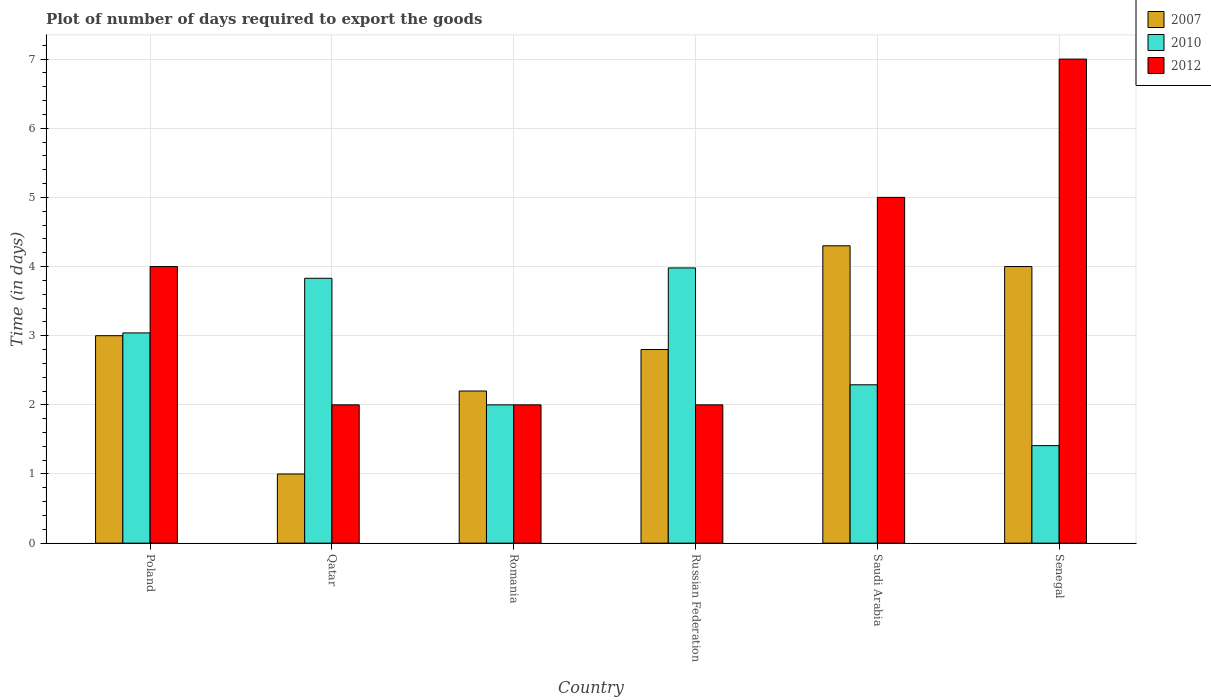How many groups of bars are there?
Provide a short and direct response. 6. How many bars are there on the 1st tick from the left?
Your answer should be very brief. 3. What is the label of the 3rd group of bars from the left?
Make the answer very short. Romania. In how many cases, is the number of bars for a given country not equal to the number of legend labels?
Offer a terse response. 0. What is the time required to export goods in 2012 in Senegal?
Your answer should be very brief. 7. Across all countries, what is the maximum time required to export goods in 2012?
Provide a succinct answer. 7. In which country was the time required to export goods in 2012 maximum?
Offer a very short reply. Senegal. In which country was the time required to export goods in 2007 minimum?
Make the answer very short. Qatar. What is the total time required to export goods in 2007 in the graph?
Offer a terse response. 17.3. What is the difference between the time required to export goods in 2007 in Romania and that in Russian Federation?
Give a very brief answer. -0.6. What is the difference between the time required to export goods in 2012 in Poland and the time required to export goods in 2010 in Senegal?
Provide a succinct answer. 2.59. What is the average time required to export goods in 2010 per country?
Keep it short and to the point. 2.76. In how many countries, is the time required to export goods in 2012 greater than 3.6 days?
Keep it short and to the point. 3. What is the ratio of the time required to export goods in 2007 in Saudi Arabia to that in Senegal?
Make the answer very short. 1.07. Is the time required to export goods in 2012 in Qatar less than that in Saudi Arabia?
Offer a very short reply. Yes. What is the difference between the highest and the second highest time required to export goods in 2007?
Provide a short and direct response. -1.3. What does the 1st bar from the left in Saudi Arabia represents?
Provide a succinct answer. 2007. What does the 2nd bar from the right in Qatar represents?
Provide a succinct answer. 2010. Is it the case that in every country, the sum of the time required to export goods in 2012 and time required to export goods in 2010 is greater than the time required to export goods in 2007?
Offer a terse response. Yes. Are all the bars in the graph horizontal?
Provide a succinct answer. No. How many countries are there in the graph?
Your answer should be compact. 6. What is the difference between two consecutive major ticks on the Y-axis?
Provide a succinct answer. 1. Are the values on the major ticks of Y-axis written in scientific E-notation?
Make the answer very short. No. How are the legend labels stacked?
Your response must be concise. Vertical. What is the title of the graph?
Ensure brevity in your answer.  Plot of number of days required to export the goods. What is the label or title of the Y-axis?
Offer a very short reply. Time (in days). What is the Time (in days) of 2007 in Poland?
Your answer should be very brief. 3. What is the Time (in days) in 2010 in Poland?
Your response must be concise. 3.04. What is the Time (in days) in 2012 in Poland?
Keep it short and to the point. 4. What is the Time (in days) of 2007 in Qatar?
Your answer should be very brief. 1. What is the Time (in days) in 2010 in Qatar?
Provide a succinct answer. 3.83. What is the Time (in days) in 2007 in Romania?
Make the answer very short. 2.2. What is the Time (in days) in 2007 in Russian Federation?
Your answer should be very brief. 2.8. What is the Time (in days) in 2010 in Russian Federation?
Offer a terse response. 3.98. What is the Time (in days) of 2012 in Russian Federation?
Give a very brief answer. 2. What is the Time (in days) in 2010 in Saudi Arabia?
Offer a terse response. 2.29. What is the Time (in days) in 2012 in Saudi Arabia?
Offer a terse response. 5. What is the Time (in days) in 2010 in Senegal?
Your response must be concise. 1.41. What is the Time (in days) in 2012 in Senegal?
Provide a succinct answer. 7. Across all countries, what is the maximum Time (in days) of 2010?
Make the answer very short. 3.98. Across all countries, what is the minimum Time (in days) of 2010?
Your answer should be very brief. 1.41. What is the total Time (in days) of 2007 in the graph?
Your response must be concise. 17.3. What is the total Time (in days) of 2010 in the graph?
Offer a terse response. 16.55. What is the difference between the Time (in days) of 2007 in Poland and that in Qatar?
Provide a succinct answer. 2. What is the difference between the Time (in days) in 2010 in Poland and that in Qatar?
Give a very brief answer. -0.79. What is the difference between the Time (in days) in 2007 in Poland and that in Romania?
Your answer should be compact. 0.8. What is the difference between the Time (in days) in 2010 in Poland and that in Romania?
Your response must be concise. 1.04. What is the difference between the Time (in days) of 2012 in Poland and that in Romania?
Offer a terse response. 2. What is the difference between the Time (in days) of 2010 in Poland and that in Russian Federation?
Ensure brevity in your answer.  -0.94. What is the difference between the Time (in days) of 2007 in Poland and that in Saudi Arabia?
Your answer should be compact. -1.3. What is the difference between the Time (in days) of 2010 in Poland and that in Saudi Arabia?
Give a very brief answer. 0.75. What is the difference between the Time (in days) of 2012 in Poland and that in Saudi Arabia?
Give a very brief answer. -1. What is the difference between the Time (in days) of 2007 in Poland and that in Senegal?
Give a very brief answer. -1. What is the difference between the Time (in days) in 2010 in Poland and that in Senegal?
Keep it short and to the point. 1.63. What is the difference between the Time (in days) in 2010 in Qatar and that in Romania?
Provide a short and direct response. 1.83. What is the difference between the Time (in days) in 2010 in Qatar and that in Saudi Arabia?
Keep it short and to the point. 1.54. What is the difference between the Time (in days) in 2007 in Qatar and that in Senegal?
Keep it short and to the point. -3. What is the difference between the Time (in days) of 2010 in Qatar and that in Senegal?
Offer a terse response. 2.42. What is the difference between the Time (in days) of 2007 in Romania and that in Russian Federation?
Your response must be concise. -0.6. What is the difference between the Time (in days) in 2010 in Romania and that in Russian Federation?
Your answer should be very brief. -1.98. What is the difference between the Time (in days) in 2010 in Romania and that in Saudi Arabia?
Your answer should be very brief. -0.29. What is the difference between the Time (in days) in 2012 in Romania and that in Saudi Arabia?
Keep it short and to the point. -3. What is the difference between the Time (in days) in 2007 in Romania and that in Senegal?
Your answer should be very brief. -1.8. What is the difference between the Time (in days) in 2010 in Romania and that in Senegal?
Ensure brevity in your answer.  0.59. What is the difference between the Time (in days) of 2012 in Romania and that in Senegal?
Your answer should be compact. -5. What is the difference between the Time (in days) in 2007 in Russian Federation and that in Saudi Arabia?
Ensure brevity in your answer.  -1.5. What is the difference between the Time (in days) of 2010 in Russian Federation and that in Saudi Arabia?
Offer a very short reply. 1.69. What is the difference between the Time (in days) of 2007 in Russian Federation and that in Senegal?
Keep it short and to the point. -1.2. What is the difference between the Time (in days) in 2010 in Russian Federation and that in Senegal?
Keep it short and to the point. 2.57. What is the difference between the Time (in days) in 2012 in Russian Federation and that in Senegal?
Your answer should be compact. -5. What is the difference between the Time (in days) in 2007 in Saudi Arabia and that in Senegal?
Give a very brief answer. 0.3. What is the difference between the Time (in days) of 2012 in Saudi Arabia and that in Senegal?
Give a very brief answer. -2. What is the difference between the Time (in days) in 2007 in Poland and the Time (in days) in 2010 in Qatar?
Keep it short and to the point. -0.83. What is the difference between the Time (in days) of 2007 in Poland and the Time (in days) of 2012 in Romania?
Provide a short and direct response. 1. What is the difference between the Time (in days) of 2007 in Poland and the Time (in days) of 2010 in Russian Federation?
Your answer should be compact. -0.98. What is the difference between the Time (in days) in 2007 in Poland and the Time (in days) in 2012 in Russian Federation?
Keep it short and to the point. 1. What is the difference between the Time (in days) of 2007 in Poland and the Time (in days) of 2010 in Saudi Arabia?
Ensure brevity in your answer.  0.71. What is the difference between the Time (in days) of 2007 in Poland and the Time (in days) of 2012 in Saudi Arabia?
Offer a terse response. -2. What is the difference between the Time (in days) in 2010 in Poland and the Time (in days) in 2012 in Saudi Arabia?
Your response must be concise. -1.96. What is the difference between the Time (in days) in 2007 in Poland and the Time (in days) in 2010 in Senegal?
Give a very brief answer. 1.59. What is the difference between the Time (in days) of 2007 in Poland and the Time (in days) of 2012 in Senegal?
Provide a short and direct response. -4. What is the difference between the Time (in days) of 2010 in Poland and the Time (in days) of 2012 in Senegal?
Keep it short and to the point. -3.96. What is the difference between the Time (in days) of 2007 in Qatar and the Time (in days) of 2010 in Romania?
Offer a very short reply. -1. What is the difference between the Time (in days) in 2010 in Qatar and the Time (in days) in 2012 in Romania?
Offer a terse response. 1.83. What is the difference between the Time (in days) of 2007 in Qatar and the Time (in days) of 2010 in Russian Federation?
Your answer should be very brief. -2.98. What is the difference between the Time (in days) of 2007 in Qatar and the Time (in days) of 2012 in Russian Federation?
Offer a very short reply. -1. What is the difference between the Time (in days) of 2010 in Qatar and the Time (in days) of 2012 in Russian Federation?
Give a very brief answer. 1.83. What is the difference between the Time (in days) of 2007 in Qatar and the Time (in days) of 2010 in Saudi Arabia?
Your answer should be compact. -1.29. What is the difference between the Time (in days) of 2007 in Qatar and the Time (in days) of 2012 in Saudi Arabia?
Provide a succinct answer. -4. What is the difference between the Time (in days) of 2010 in Qatar and the Time (in days) of 2012 in Saudi Arabia?
Your answer should be very brief. -1.17. What is the difference between the Time (in days) of 2007 in Qatar and the Time (in days) of 2010 in Senegal?
Provide a short and direct response. -0.41. What is the difference between the Time (in days) of 2010 in Qatar and the Time (in days) of 2012 in Senegal?
Offer a very short reply. -3.17. What is the difference between the Time (in days) in 2007 in Romania and the Time (in days) in 2010 in Russian Federation?
Your answer should be very brief. -1.78. What is the difference between the Time (in days) of 2010 in Romania and the Time (in days) of 2012 in Russian Federation?
Your answer should be compact. 0. What is the difference between the Time (in days) in 2007 in Romania and the Time (in days) in 2010 in Saudi Arabia?
Ensure brevity in your answer.  -0.09. What is the difference between the Time (in days) of 2007 in Romania and the Time (in days) of 2012 in Saudi Arabia?
Provide a short and direct response. -2.8. What is the difference between the Time (in days) in 2010 in Romania and the Time (in days) in 2012 in Saudi Arabia?
Provide a succinct answer. -3. What is the difference between the Time (in days) in 2007 in Romania and the Time (in days) in 2010 in Senegal?
Provide a succinct answer. 0.79. What is the difference between the Time (in days) of 2007 in Romania and the Time (in days) of 2012 in Senegal?
Provide a short and direct response. -4.8. What is the difference between the Time (in days) in 2010 in Romania and the Time (in days) in 2012 in Senegal?
Provide a short and direct response. -5. What is the difference between the Time (in days) in 2007 in Russian Federation and the Time (in days) in 2010 in Saudi Arabia?
Offer a terse response. 0.51. What is the difference between the Time (in days) in 2010 in Russian Federation and the Time (in days) in 2012 in Saudi Arabia?
Give a very brief answer. -1.02. What is the difference between the Time (in days) in 2007 in Russian Federation and the Time (in days) in 2010 in Senegal?
Give a very brief answer. 1.39. What is the difference between the Time (in days) in 2007 in Russian Federation and the Time (in days) in 2012 in Senegal?
Make the answer very short. -4.2. What is the difference between the Time (in days) in 2010 in Russian Federation and the Time (in days) in 2012 in Senegal?
Ensure brevity in your answer.  -3.02. What is the difference between the Time (in days) of 2007 in Saudi Arabia and the Time (in days) of 2010 in Senegal?
Your answer should be compact. 2.89. What is the difference between the Time (in days) of 2010 in Saudi Arabia and the Time (in days) of 2012 in Senegal?
Offer a very short reply. -4.71. What is the average Time (in days) of 2007 per country?
Make the answer very short. 2.88. What is the average Time (in days) in 2010 per country?
Keep it short and to the point. 2.76. What is the average Time (in days) of 2012 per country?
Your answer should be compact. 3.67. What is the difference between the Time (in days) of 2007 and Time (in days) of 2010 in Poland?
Give a very brief answer. -0.04. What is the difference between the Time (in days) of 2007 and Time (in days) of 2012 in Poland?
Offer a very short reply. -1. What is the difference between the Time (in days) of 2010 and Time (in days) of 2012 in Poland?
Your answer should be compact. -0.96. What is the difference between the Time (in days) of 2007 and Time (in days) of 2010 in Qatar?
Ensure brevity in your answer.  -2.83. What is the difference between the Time (in days) in 2007 and Time (in days) in 2012 in Qatar?
Make the answer very short. -1. What is the difference between the Time (in days) of 2010 and Time (in days) of 2012 in Qatar?
Ensure brevity in your answer.  1.83. What is the difference between the Time (in days) in 2007 and Time (in days) in 2012 in Romania?
Your response must be concise. 0.2. What is the difference between the Time (in days) in 2010 and Time (in days) in 2012 in Romania?
Ensure brevity in your answer.  0. What is the difference between the Time (in days) in 2007 and Time (in days) in 2010 in Russian Federation?
Provide a succinct answer. -1.18. What is the difference between the Time (in days) in 2007 and Time (in days) in 2012 in Russian Federation?
Your response must be concise. 0.8. What is the difference between the Time (in days) in 2010 and Time (in days) in 2012 in Russian Federation?
Offer a very short reply. 1.98. What is the difference between the Time (in days) in 2007 and Time (in days) in 2010 in Saudi Arabia?
Keep it short and to the point. 2.01. What is the difference between the Time (in days) in 2007 and Time (in days) in 2012 in Saudi Arabia?
Ensure brevity in your answer.  -0.7. What is the difference between the Time (in days) of 2010 and Time (in days) of 2012 in Saudi Arabia?
Offer a terse response. -2.71. What is the difference between the Time (in days) in 2007 and Time (in days) in 2010 in Senegal?
Offer a terse response. 2.59. What is the difference between the Time (in days) in 2010 and Time (in days) in 2012 in Senegal?
Provide a short and direct response. -5.59. What is the ratio of the Time (in days) of 2010 in Poland to that in Qatar?
Offer a very short reply. 0.79. What is the ratio of the Time (in days) in 2012 in Poland to that in Qatar?
Your response must be concise. 2. What is the ratio of the Time (in days) in 2007 in Poland to that in Romania?
Your answer should be very brief. 1.36. What is the ratio of the Time (in days) of 2010 in Poland to that in Romania?
Your answer should be compact. 1.52. What is the ratio of the Time (in days) of 2007 in Poland to that in Russian Federation?
Keep it short and to the point. 1.07. What is the ratio of the Time (in days) in 2010 in Poland to that in Russian Federation?
Keep it short and to the point. 0.76. What is the ratio of the Time (in days) of 2007 in Poland to that in Saudi Arabia?
Provide a short and direct response. 0.7. What is the ratio of the Time (in days) of 2010 in Poland to that in Saudi Arabia?
Ensure brevity in your answer.  1.33. What is the ratio of the Time (in days) of 2010 in Poland to that in Senegal?
Make the answer very short. 2.16. What is the ratio of the Time (in days) in 2012 in Poland to that in Senegal?
Your answer should be very brief. 0.57. What is the ratio of the Time (in days) in 2007 in Qatar to that in Romania?
Your response must be concise. 0.45. What is the ratio of the Time (in days) in 2010 in Qatar to that in Romania?
Provide a short and direct response. 1.92. What is the ratio of the Time (in days) of 2012 in Qatar to that in Romania?
Your response must be concise. 1. What is the ratio of the Time (in days) in 2007 in Qatar to that in Russian Federation?
Ensure brevity in your answer.  0.36. What is the ratio of the Time (in days) in 2010 in Qatar to that in Russian Federation?
Ensure brevity in your answer.  0.96. What is the ratio of the Time (in days) in 2007 in Qatar to that in Saudi Arabia?
Provide a short and direct response. 0.23. What is the ratio of the Time (in days) in 2010 in Qatar to that in Saudi Arabia?
Keep it short and to the point. 1.67. What is the ratio of the Time (in days) of 2010 in Qatar to that in Senegal?
Your response must be concise. 2.72. What is the ratio of the Time (in days) of 2012 in Qatar to that in Senegal?
Give a very brief answer. 0.29. What is the ratio of the Time (in days) of 2007 in Romania to that in Russian Federation?
Your answer should be compact. 0.79. What is the ratio of the Time (in days) of 2010 in Romania to that in Russian Federation?
Offer a terse response. 0.5. What is the ratio of the Time (in days) in 2012 in Romania to that in Russian Federation?
Give a very brief answer. 1. What is the ratio of the Time (in days) of 2007 in Romania to that in Saudi Arabia?
Keep it short and to the point. 0.51. What is the ratio of the Time (in days) in 2010 in Romania to that in Saudi Arabia?
Provide a succinct answer. 0.87. What is the ratio of the Time (in days) in 2007 in Romania to that in Senegal?
Your answer should be compact. 0.55. What is the ratio of the Time (in days) in 2010 in Romania to that in Senegal?
Keep it short and to the point. 1.42. What is the ratio of the Time (in days) in 2012 in Romania to that in Senegal?
Your answer should be compact. 0.29. What is the ratio of the Time (in days) in 2007 in Russian Federation to that in Saudi Arabia?
Make the answer very short. 0.65. What is the ratio of the Time (in days) of 2010 in Russian Federation to that in Saudi Arabia?
Offer a very short reply. 1.74. What is the ratio of the Time (in days) in 2007 in Russian Federation to that in Senegal?
Offer a terse response. 0.7. What is the ratio of the Time (in days) in 2010 in Russian Federation to that in Senegal?
Keep it short and to the point. 2.82. What is the ratio of the Time (in days) in 2012 in Russian Federation to that in Senegal?
Your answer should be very brief. 0.29. What is the ratio of the Time (in days) in 2007 in Saudi Arabia to that in Senegal?
Provide a short and direct response. 1.07. What is the ratio of the Time (in days) of 2010 in Saudi Arabia to that in Senegal?
Ensure brevity in your answer.  1.62. What is the ratio of the Time (in days) of 2012 in Saudi Arabia to that in Senegal?
Offer a terse response. 0.71. What is the difference between the highest and the second highest Time (in days) of 2010?
Provide a short and direct response. 0.15. What is the difference between the highest and the second highest Time (in days) in 2012?
Keep it short and to the point. 2. What is the difference between the highest and the lowest Time (in days) in 2010?
Keep it short and to the point. 2.57. 